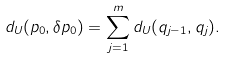<formula> <loc_0><loc_0><loc_500><loc_500>d _ { U } ( p _ { 0 } , \delta p _ { 0 } ) = \sum _ { j = 1 } ^ { m } d _ { U } ( q _ { j - 1 } , q _ { j } ) .</formula> 